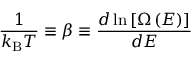<formula> <loc_0><loc_0><loc_500><loc_500>{ \frac { 1 } { k _ { B } T } } \equiv \beta \equiv \frac { d \ln \left [ \Omega \left ( E \right ) \right ] } { d E }</formula> 